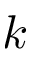Convert formula to latex. <formula><loc_0><loc_0><loc_500><loc_500>k</formula> 